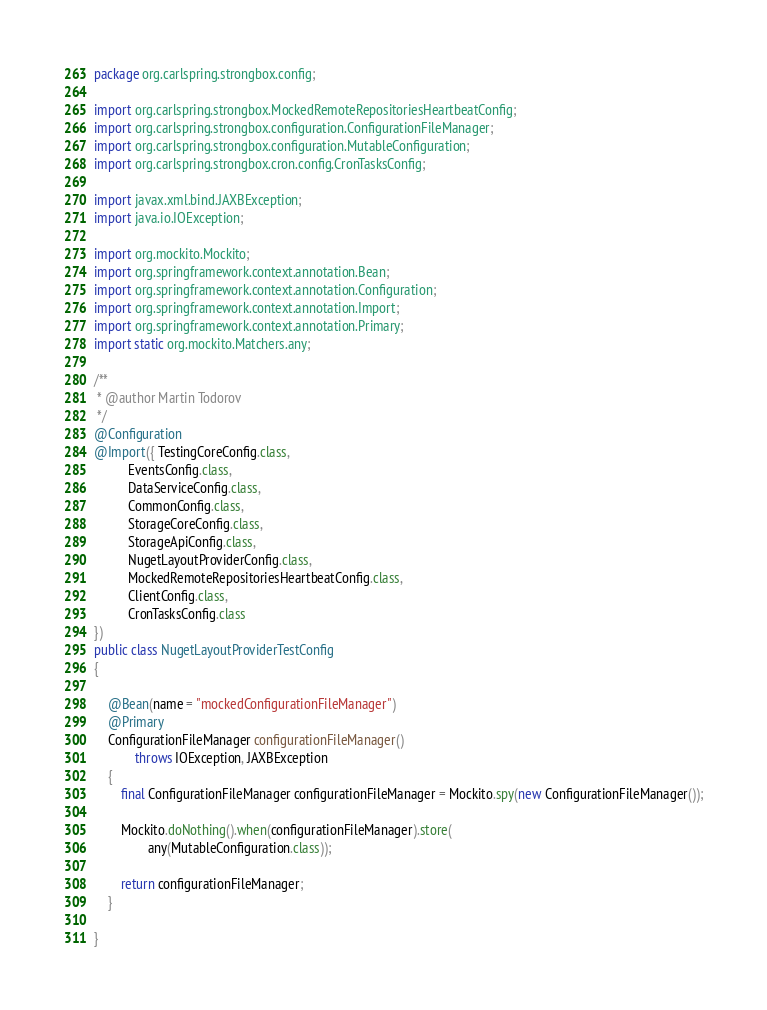<code> <loc_0><loc_0><loc_500><loc_500><_Java_>package org.carlspring.strongbox.config;

import org.carlspring.strongbox.MockedRemoteRepositoriesHeartbeatConfig;
import org.carlspring.strongbox.configuration.ConfigurationFileManager;
import org.carlspring.strongbox.configuration.MutableConfiguration;
import org.carlspring.strongbox.cron.config.CronTasksConfig;

import javax.xml.bind.JAXBException;
import java.io.IOException;

import org.mockito.Mockito;
import org.springframework.context.annotation.Bean;
import org.springframework.context.annotation.Configuration;
import org.springframework.context.annotation.Import;
import org.springframework.context.annotation.Primary;
import static org.mockito.Matchers.any;

/**
 * @author Martin Todorov
 */
@Configuration
@Import({ TestingCoreConfig.class,
          EventsConfig.class,
          DataServiceConfig.class,
          CommonConfig.class,
          StorageCoreConfig.class,
          StorageApiConfig.class,
          NugetLayoutProviderConfig.class,
          MockedRemoteRepositoriesHeartbeatConfig.class,
          ClientConfig.class,
          CronTasksConfig.class
})
public class NugetLayoutProviderTestConfig
{

    @Bean(name = "mockedConfigurationFileManager")
    @Primary
    ConfigurationFileManager configurationFileManager()
            throws IOException, JAXBException
    {
        final ConfigurationFileManager configurationFileManager = Mockito.spy(new ConfigurationFileManager());

        Mockito.doNothing().when(configurationFileManager).store(
                any(MutableConfiguration.class));

        return configurationFileManager;
    }

}
</code> 